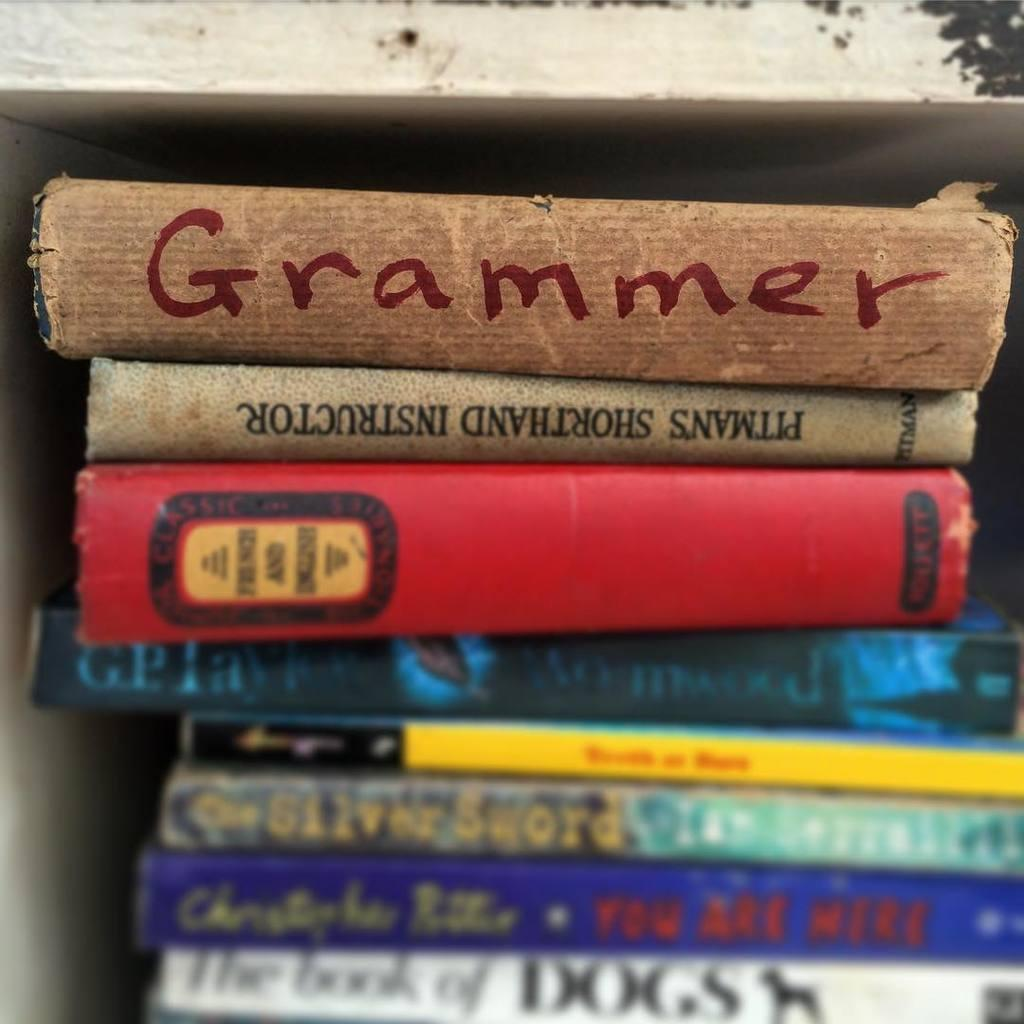What type of objects can be seen in the image? There are books in the image. Can you describe the appearance of the books? The books have text visible on them. What type of net can be seen surrounding the books in the image? There is no net present in the image; it only features books with visible text. 